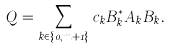<formula> <loc_0><loc_0><loc_500><loc_500>Q = \sum _ { k \in \{ 0 , m + 1 \} } c _ { k } B _ { k } ^ { \ast } A _ { k } B _ { k } .</formula> 